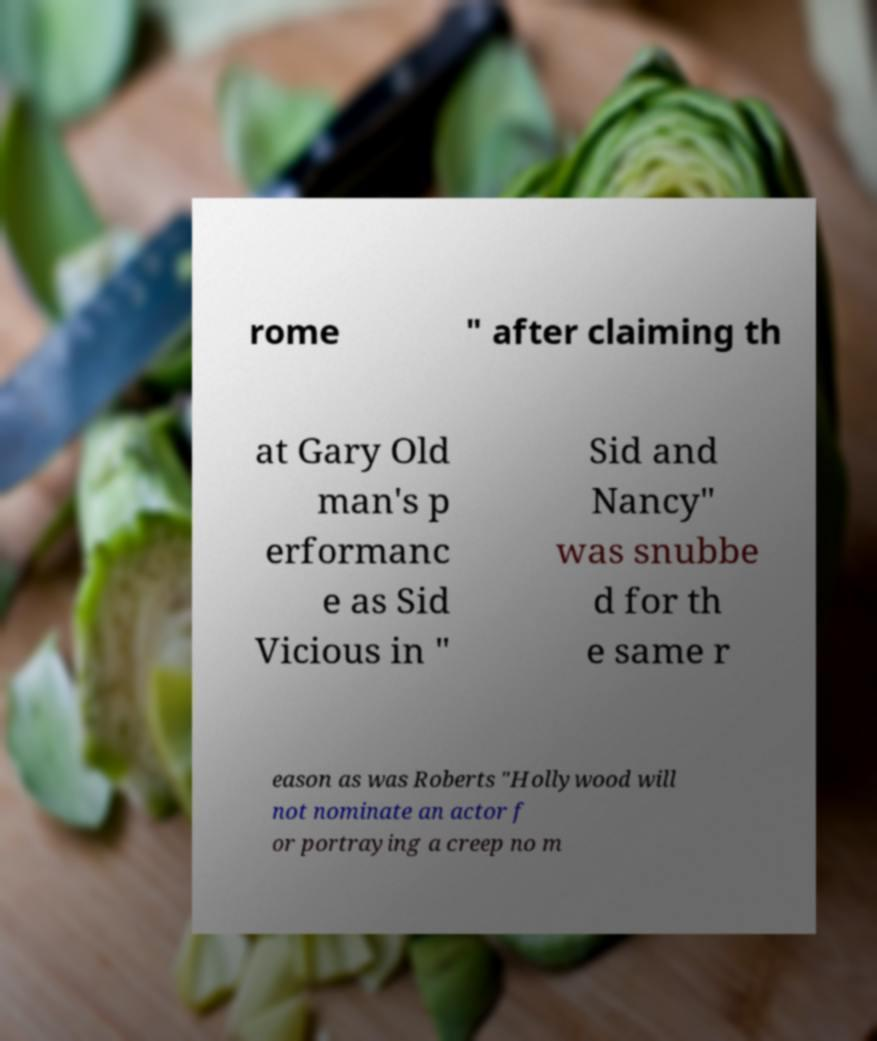Can you accurately transcribe the text from the provided image for me? rome " after claiming th at Gary Old man's p erformanc e as Sid Vicious in " Sid and Nancy" was snubbe d for th e same r eason as was Roberts "Hollywood will not nominate an actor f or portraying a creep no m 